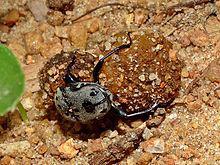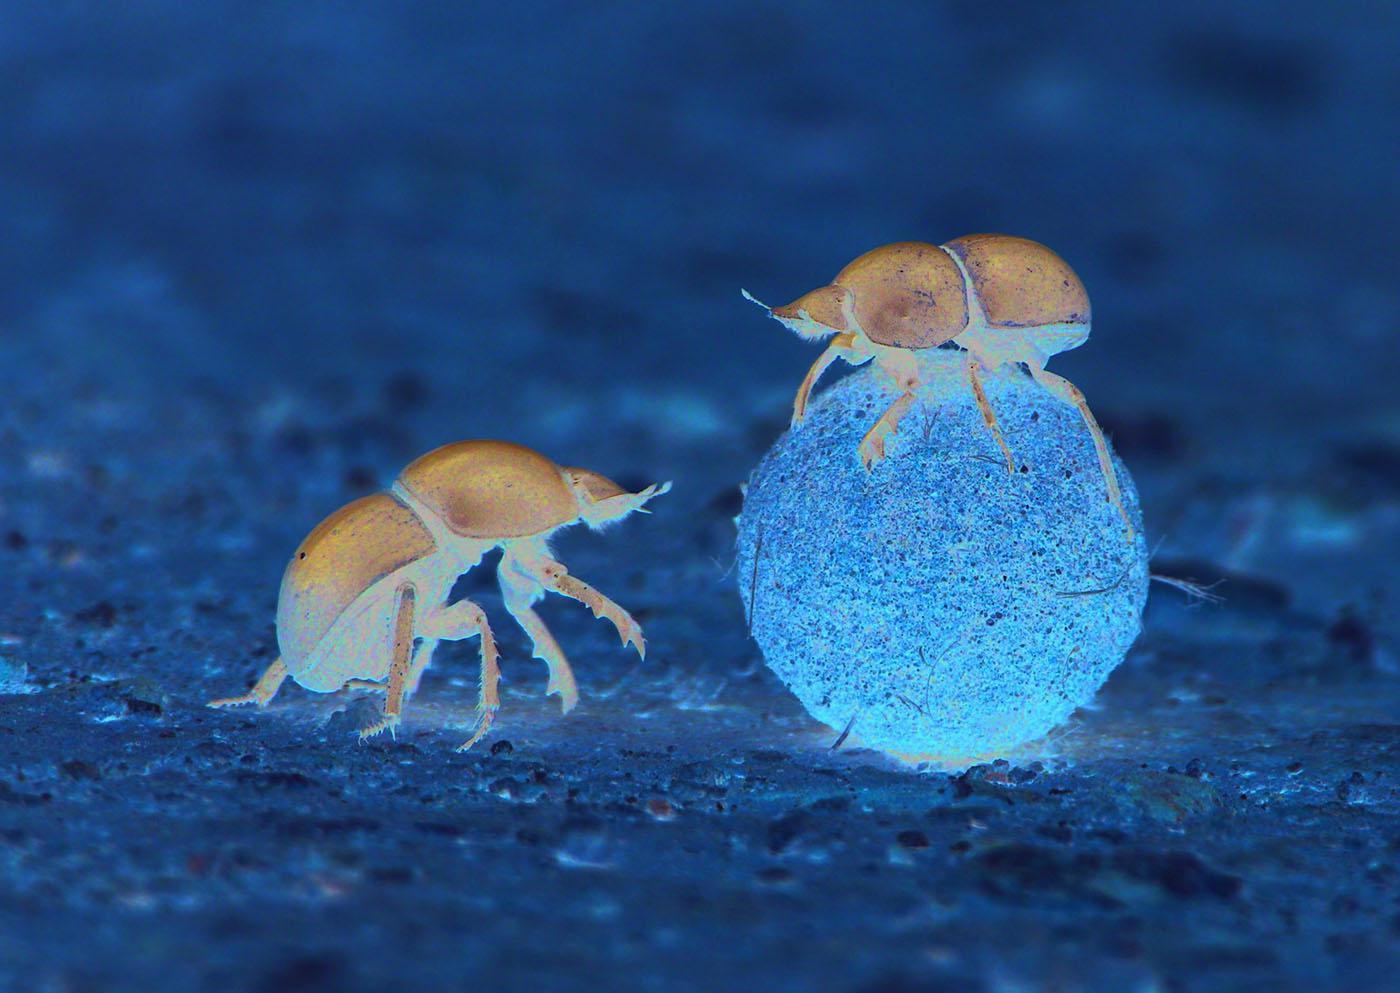The first image is the image on the left, the second image is the image on the right. Examine the images to the left and right. Is the description "There are no more than two dung beetles." accurate? Answer yes or no. No. The first image is the image on the left, the second image is the image on the right. Given the left and right images, does the statement "In one of the images, more than one beetle is seen, interacting with the 'ball'." hold true? Answer yes or no. Yes. 